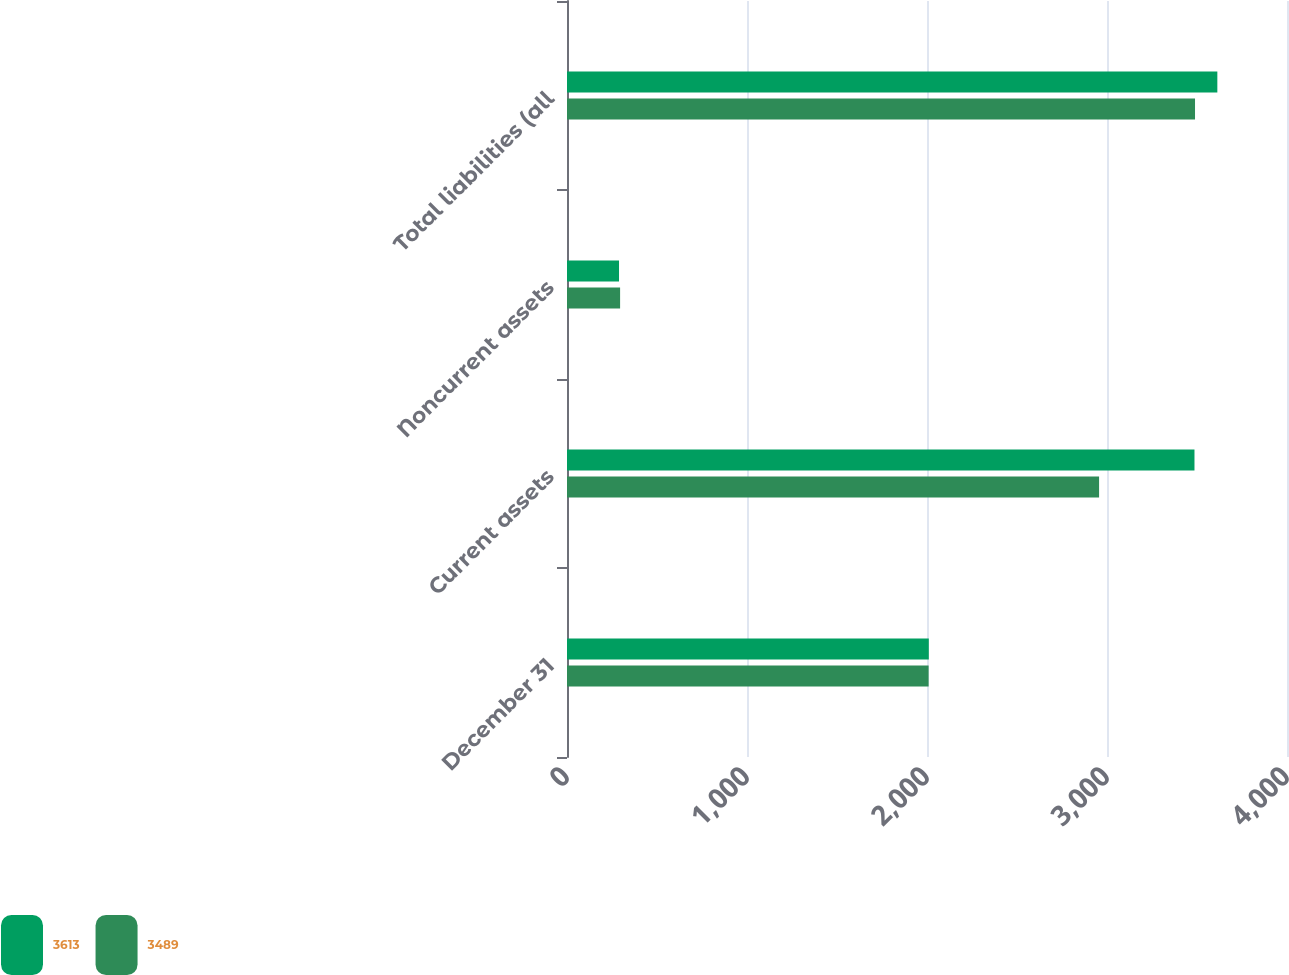Convert chart. <chart><loc_0><loc_0><loc_500><loc_500><stacked_bar_chart><ecel><fcel>December 31<fcel>Current assets<fcel>Noncurrent assets<fcel>Total liabilities (all<nl><fcel>3613<fcel>2010<fcel>3486<fcel>289<fcel>3613<nl><fcel>3489<fcel>2009<fcel>2956<fcel>295<fcel>3489<nl></chart> 